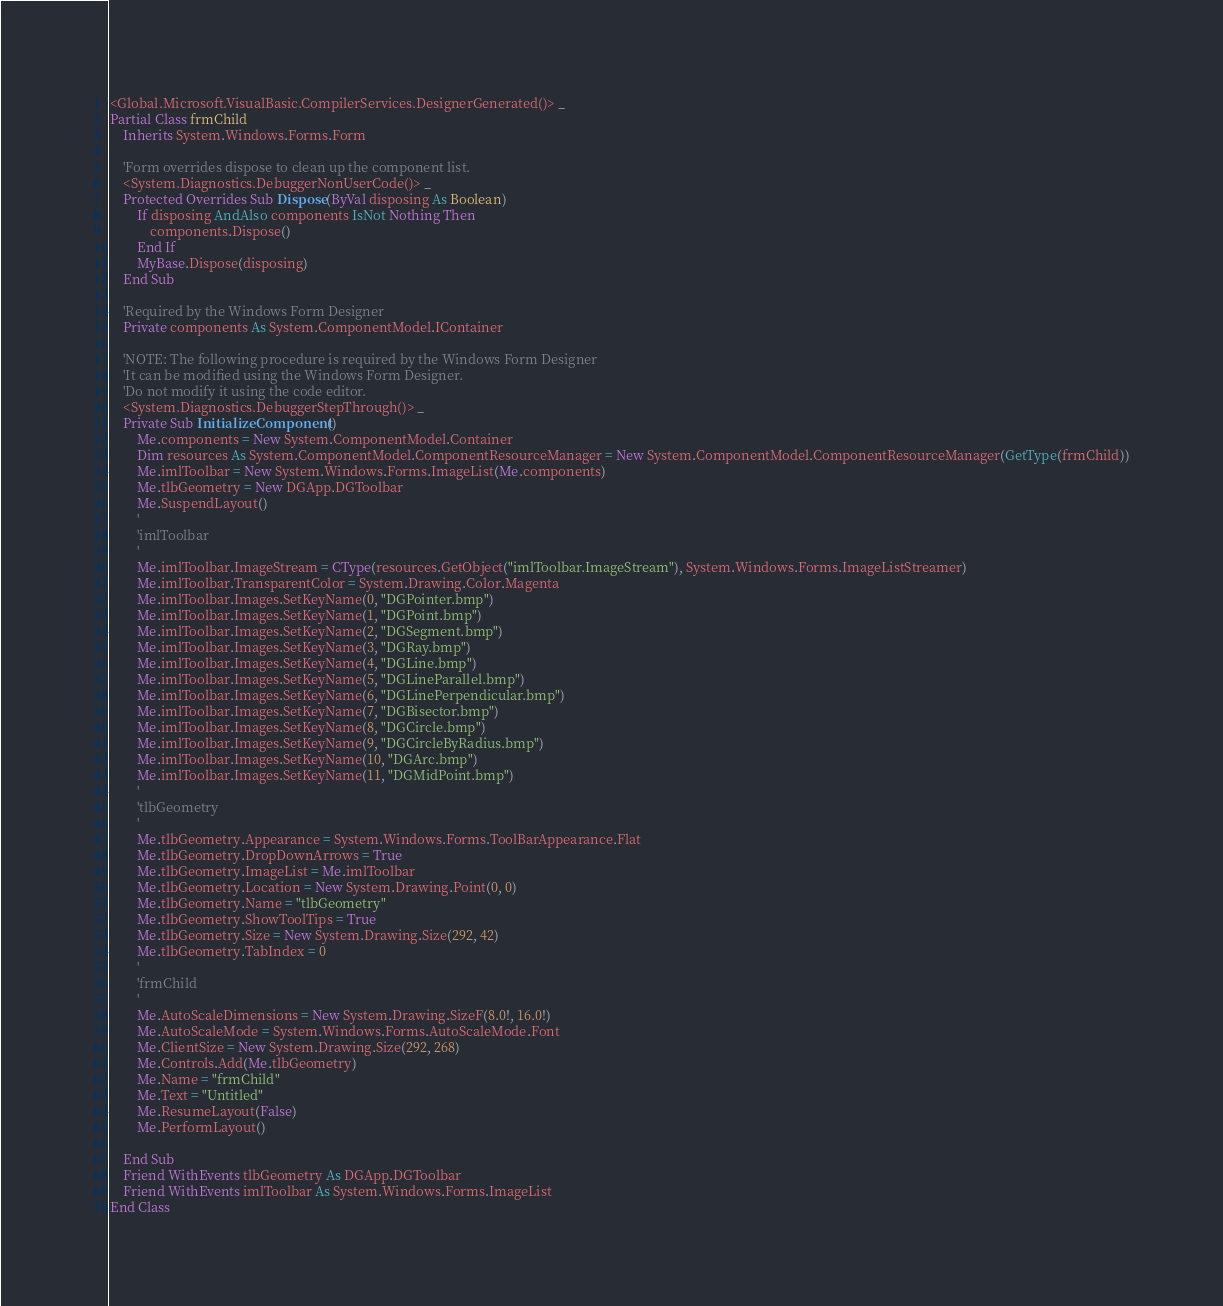Convert code to text. <code><loc_0><loc_0><loc_500><loc_500><_VisualBasic_><Global.Microsoft.VisualBasic.CompilerServices.DesignerGenerated()> _
Partial Class frmChild
    Inherits System.Windows.Forms.Form

    'Form overrides dispose to clean up the component list.
    <System.Diagnostics.DebuggerNonUserCode()> _
    Protected Overrides Sub Dispose(ByVal disposing As Boolean)
        If disposing AndAlso components IsNot Nothing Then
            components.Dispose()
        End If
        MyBase.Dispose(disposing)
    End Sub

    'Required by the Windows Form Designer
    Private components As System.ComponentModel.IContainer

    'NOTE: The following procedure is required by the Windows Form Designer
    'It can be modified using the Windows Form Designer.  
    'Do not modify it using the code editor.
    <System.Diagnostics.DebuggerStepThrough()> _
    Private Sub InitializeComponent()
		Me.components = New System.ComponentModel.Container
		Dim resources As System.ComponentModel.ComponentResourceManager = New System.ComponentModel.ComponentResourceManager(GetType(frmChild))
		Me.imlToolbar = New System.Windows.Forms.ImageList(Me.components)
		Me.tlbGeometry = New DGApp.DGToolbar
		Me.SuspendLayout()
		'
		'imlToolbar
		'
		Me.imlToolbar.ImageStream = CType(resources.GetObject("imlToolbar.ImageStream"), System.Windows.Forms.ImageListStreamer)
		Me.imlToolbar.TransparentColor = System.Drawing.Color.Magenta
		Me.imlToolbar.Images.SetKeyName(0, "DGPointer.bmp")
		Me.imlToolbar.Images.SetKeyName(1, "DGPoint.bmp")
		Me.imlToolbar.Images.SetKeyName(2, "DGSegment.bmp")
		Me.imlToolbar.Images.SetKeyName(3, "DGRay.bmp")
		Me.imlToolbar.Images.SetKeyName(4, "DGLine.bmp")
		Me.imlToolbar.Images.SetKeyName(5, "DGLineParallel.bmp")
		Me.imlToolbar.Images.SetKeyName(6, "DGLinePerpendicular.bmp")
		Me.imlToolbar.Images.SetKeyName(7, "DGBisector.bmp")
		Me.imlToolbar.Images.SetKeyName(8, "DGCircle.bmp")
		Me.imlToolbar.Images.SetKeyName(9, "DGCircleByRadius.bmp")
		Me.imlToolbar.Images.SetKeyName(10, "DGArc.bmp")
		Me.imlToolbar.Images.SetKeyName(11, "DGMidPoint.bmp")
		'
		'tlbGeometry
		'
		Me.tlbGeometry.Appearance = System.Windows.Forms.ToolBarAppearance.Flat
		Me.tlbGeometry.DropDownArrows = True
		Me.tlbGeometry.ImageList = Me.imlToolbar
		Me.tlbGeometry.Location = New System.Drawing.Point(0, 0)
		Me.tlbGeometry.Name = "tlbGeometry"
		Me.tlbGeometry.ShowToolTips = True
		Me.tlbGeometry.Size = New System.Drawing.Size(292, 42)
		Me.tlbGeometry.TabIndex = 0
		'
		'frmChild
		'
		Me.AutoScaleDimensions = New System.Drawing.SizeF(8.0!, 16.0!)
		Me.AutoScaleMode = System.Windows.Forms.AutoScaleMode.Font
		Me.ClientSize = New System.Drawing.Size(292, 268)
		Me.Controls.Add(Me.tlbGeometry)
		Me.Name = "frmChild"
		Me.Text = "Untitled"
		Me.ResumeLayout(False)
		Me.PerformLayout()

	End Sub
	Friend WithEvents tlbGeometry As DGApp.DGToolbar
	Friend WithEvents imlToolbar As System.Windows.Forms.ImageList
End Class
</code> 